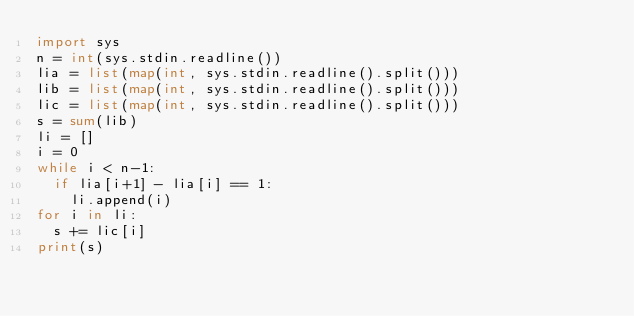<code> <loc_0><loc_0><loc_500><loc_500><_Python_>import sys
n = int(sys.stdin.readline())
lia = list(map(int, sys.stdin.readline().split()))
lib = list(map(int, sys.stdin.readline().split()))
lic = list(map(int, sys.stdin.readline().split()))
s = sum(lib)
li = []
i = 0
while i < n-1:
  if lia[i+1] - lia[i] == 1:
    li.append(i)
for i in li:
  s += lic[i]
print(s)</code> 